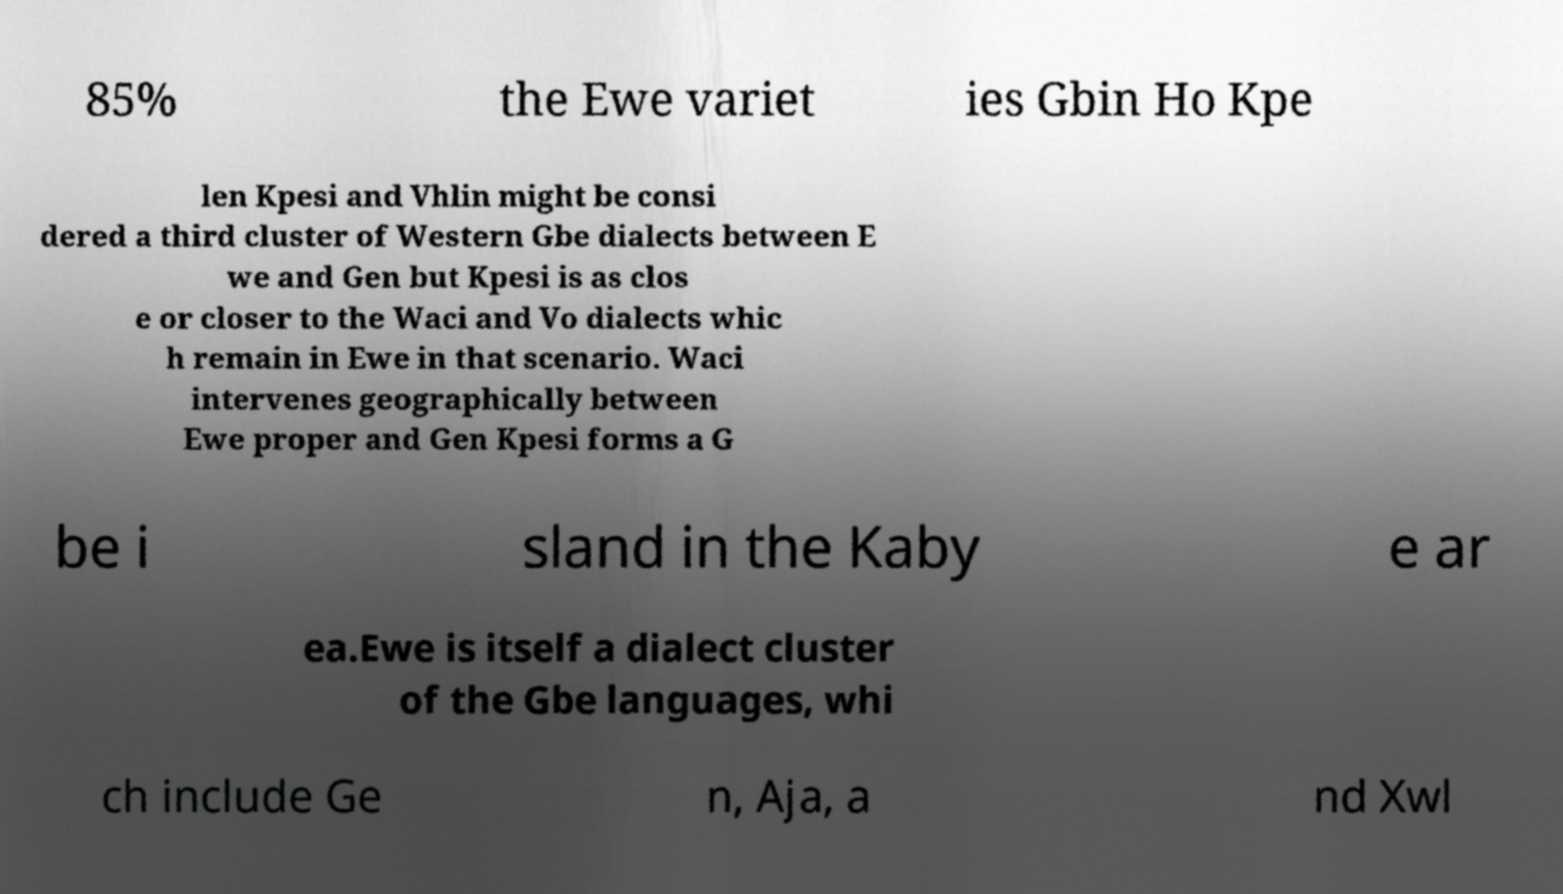I need the written content from this picture converted into text. Can you do that? 85% the Ewe variet ies Gbin Ho Kpe len Kpesi and Vhlin might be consi dered a third cluster of Western Gbe dialects between E we and Gen but Kpesi is as clos e or closer to the Waci and Vo dialects whic h remain in Ewe in that scenario. Waci intervenes geographically between Ewe proper and Gen Kpesi forms a G be i sland in the Kaby e ar ea.Ewe is itself a dialect cluster of the Gbe languages, whi ch include Ge n, Aja, a nd Xwl 